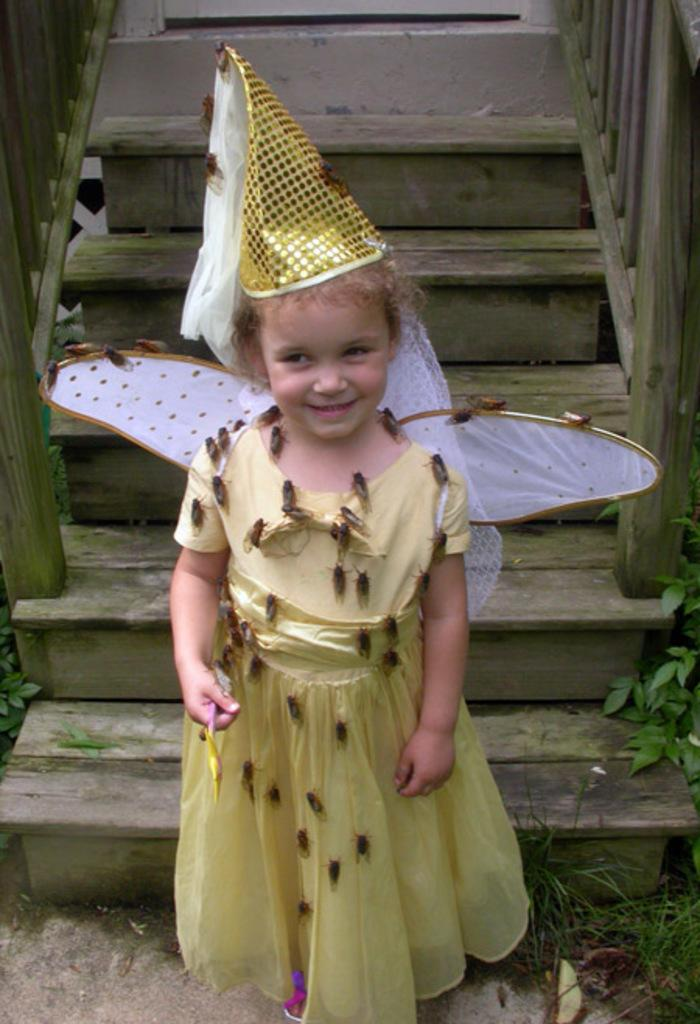What is the main subject of the image? The main subject of the image is a kid. What is the kid wearing in the image? The kid is wearing clothes in the image. Where is the kid standing in the image? The kid is standing in front of a staircase in the image. What type of vegetation is present in the image? There is a plant and grass in the image. What type of winter experience can be seen in the image? There is no reference to winter or any specific experience in the image; it simply features a kid standing in front of a staircase with a plant and grass nearby. 